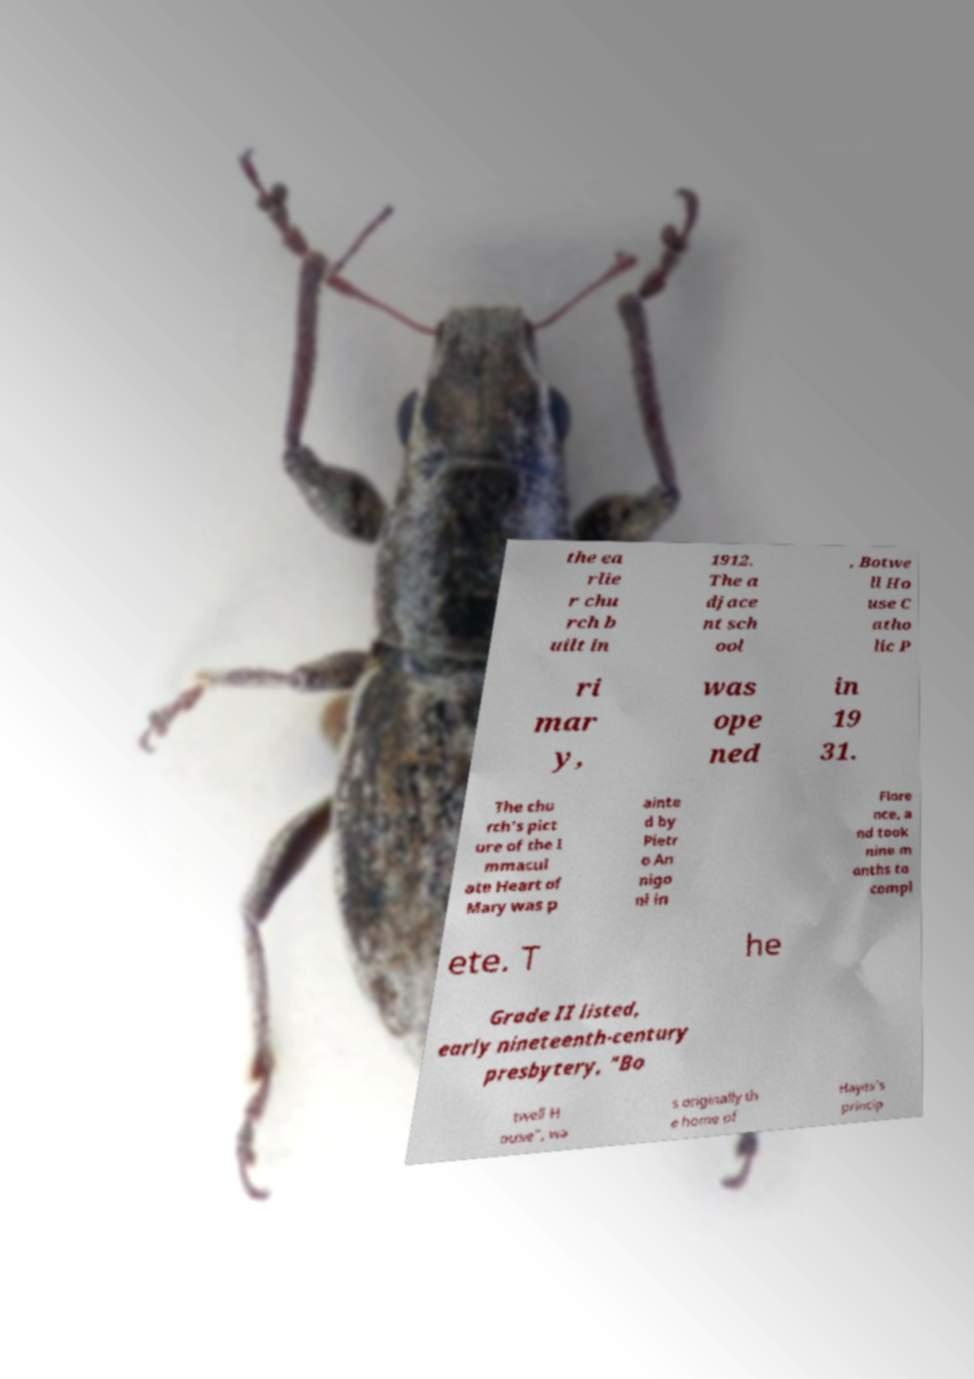For documentation purposes, I need the text within this image transcribed. Could you provide that? the ea rlie r chu rch b uilt in 1912. The a djace nt sch ool , Botwe ll Ho use C atho lic P ri mar y, was ope ned in 19 31. The chu rch's pict ure of the I mmacul ate Heart of Mary was p ainte d by Pietr o An nigo ni in Flore nce, a nd took nine m onths to compl ete. T he Grade II listed, early nineteenth-century presbytery, "Bo twell H ouse", wa s originally th e home of Hayes's princip 